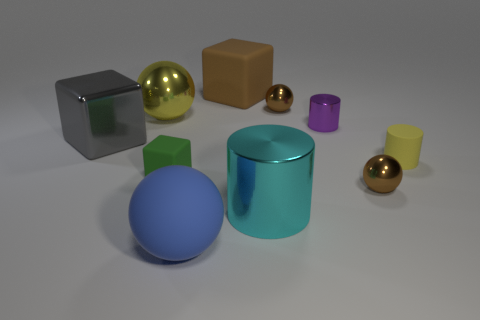Do the large yellow thing and the large brown matte thing have the same shape?
Provide a short and direct response. No. Is there any other thing of the same color as the big shiny cylinder?
Make the answer very short. No. The gray thing that is the same material as the cyan object is what shape?
Offer a very short reply. Cube. Does the green matte object have the same size as the blue sphere?
Keep it short and to the point. No. Is the material of the big sphere that is to the right of the green thing the same as the green cube?
Ensure brevity in your answer.  Yes. Are there any other things that have the same material as the gray block?
Your response must be concise. Yes. How many purple things are on the right side of the tiny metal sphere that is in front of the tiny matte cylinder in front of the purple metal thing?
Your response must be concise. 0. Is the shape of the small purple object that is behind the large rubber sphere the same as  the big blue object?
Your answer should be very brief. No. How many things are small gray metallic cylinders or tiny spheres behind the big yellow ball?
Ensure brevity in your answer.  1. Is the number of small purple metal things that are on the left side of the big metallic block greater than the number of small yellow things?
Keep it short and to the point. No. 